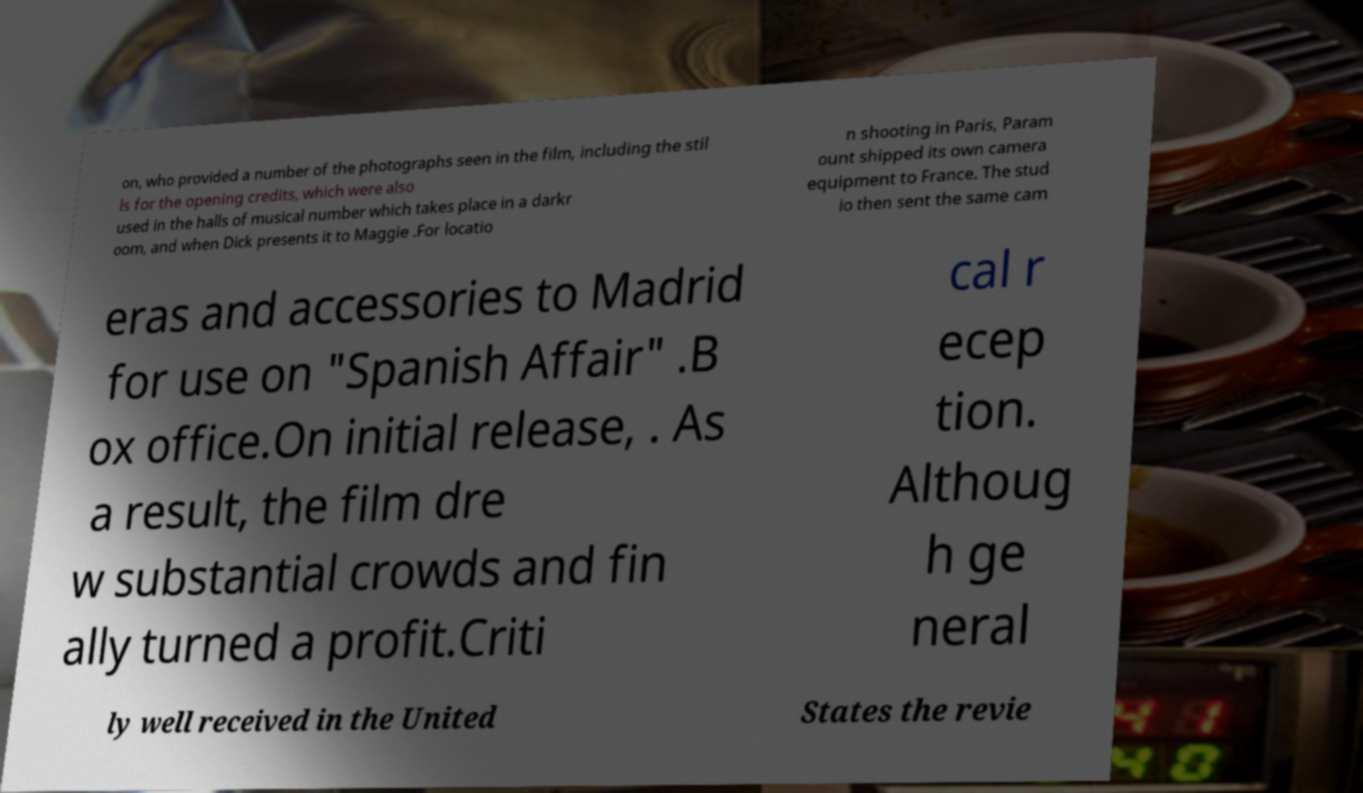Could you extract and type out the text from this image? on, who provided a number of the photographs seen in the film, including the stil ls for the opening credits, which were also used in the halls of musical number which takes place in a darkr oom, and when Dick presents it to Maggie .For locatio n shooting in Paris, Param ount shipped its own camera equipment to France. The stud io then sent the same cam eras and accessories to Madrid for use on "Spanish Affair" .B ox office.On initial release, . As a result, the film dre w substantial crowds and fin ally turned a profit.Criti cal r ecep tion. Althoug h ge neral ly well received in the United States the revie 